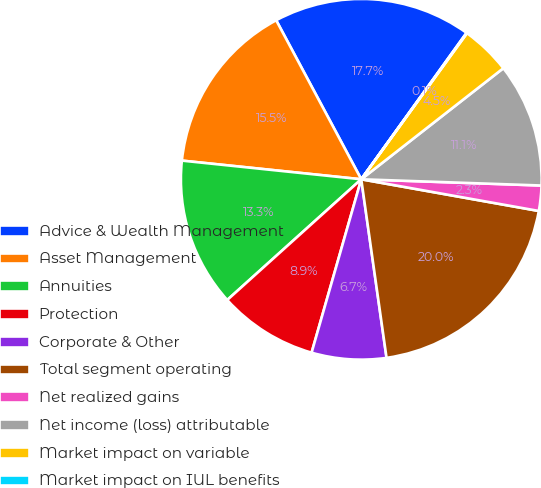Convert chart. <chart><loc_0><loc_0><loc_500><loc_500><pie_chart><fcel>Advice & Wealth Management<fcel>Asset Management<fcel>Annuities<fcel>Protection<fcel>Corporate & Other<fcel>Total segment operating<fcel>Net realized gains<fcel>Net income (loss) attributable<fcel>Market impact on variable<fcel>Market impact on IUL benefits<nl><fcel>17.74%<fcel>15.53%<fcel>13.32%<fcel>8.89%<fcel>6.68%<fcel>19.95%<fcel>2.26%<fcel>11.11%<fcel>4.47%<fcel>0.05%<nl></chart> 